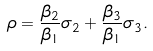Convert formula to latex. <formula><loc_0><loc_0><loc_500><loc_500>\rho = \frac { \beta _ { 2 } } { \beta _ { 1 } } \sigma _ { 2 } + \frac { \beta _ { 3 } } { \beta _ { 1 } } \sigma _ { 3 } .</formula> 